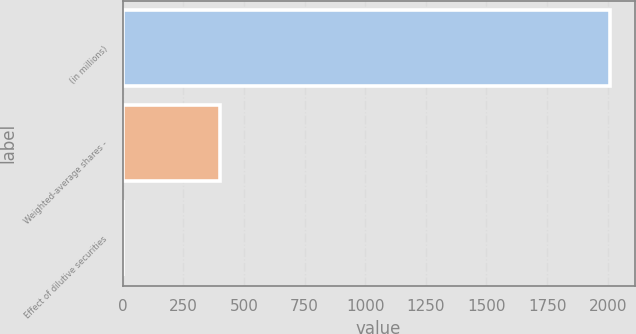Convert chart. <chart><loc_0><loc_0><loc_500><loc_500><bar_chart><fcel>(in millions)<fcel>Weighted-average shares -<fcel>Effect of dilutive securities<nl><fcel>2011<fcel>402.28<fcel>0.1<nl></chart> 